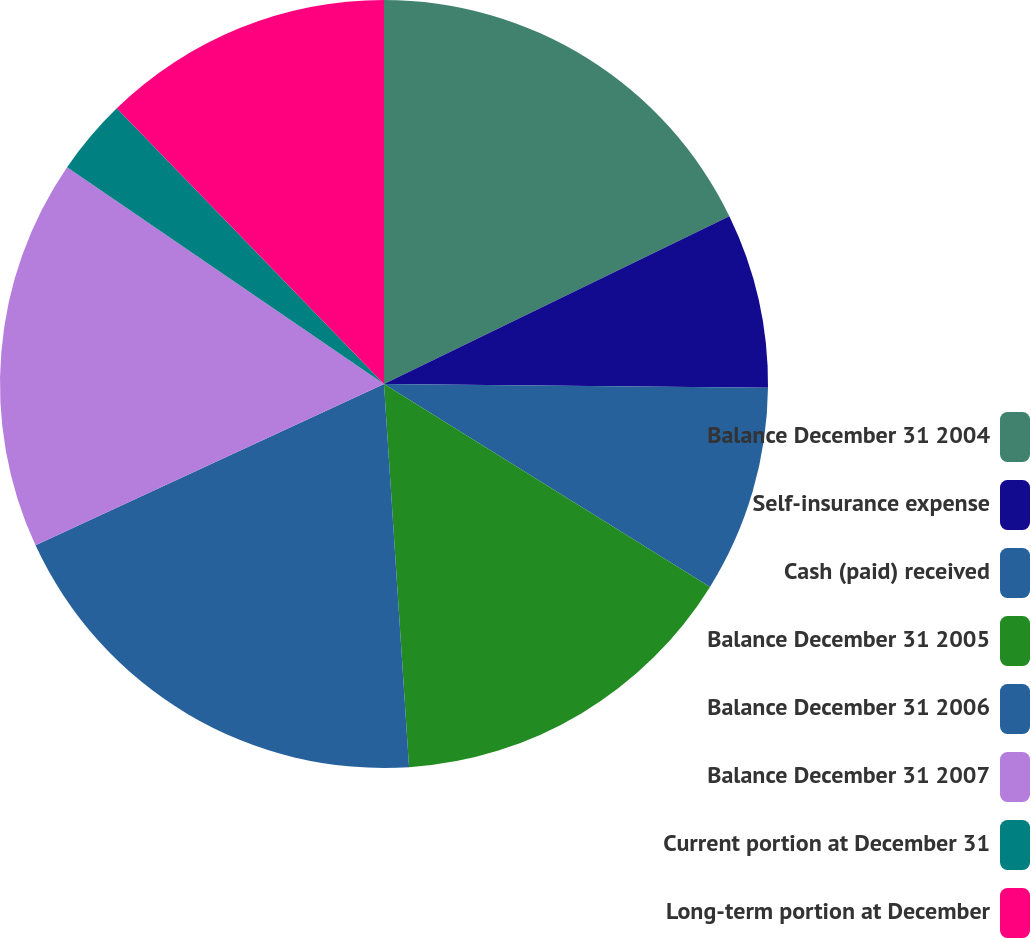Convert chart. <chart><loc_0><loc_0><loc_500><loc_500><pie_chart><fcel>Balance December 31 2004<fcel>Self-insurance expense<fcel>Cash (paid) received<fcel>Balance December 31 2005<fcel>Balance December 31 2006<fcel>Balance December 31 2007<fcel>Current portion at December 31<fcel>Long-term portion at December<nl><fcel>17.8%<fcel>7.36%<fcel>8.7%<fcel>15.1%<fcel>19.14%<fcel>16.45%<fcel>3.2%<fcel>12.25%<nl></chart> 